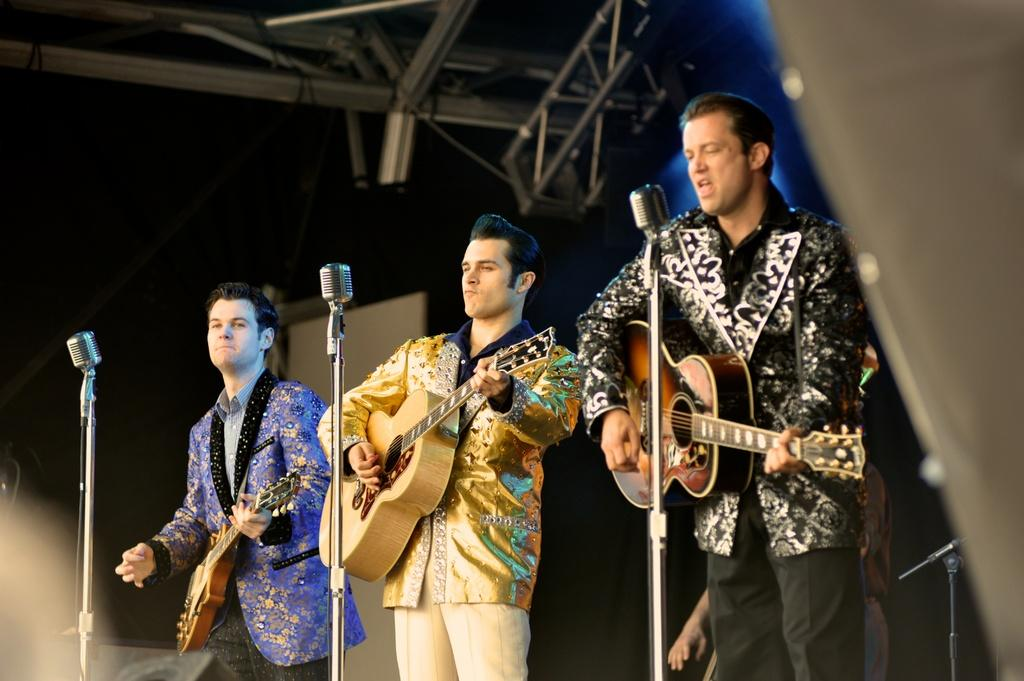How many people are in the image? There are three men in the image. What are the men doing in the image? The men are playing guitars. What object is in front of the men? There is a microphone in front of the men. What type of jeans are the men wearing in the image? The provided facts do not mention the type of jeans the men are wearing, so we cannot answer that question. What song are the men playing in the image? The provided facts do not mention the song the men are playing, so we cannot answer that question. 